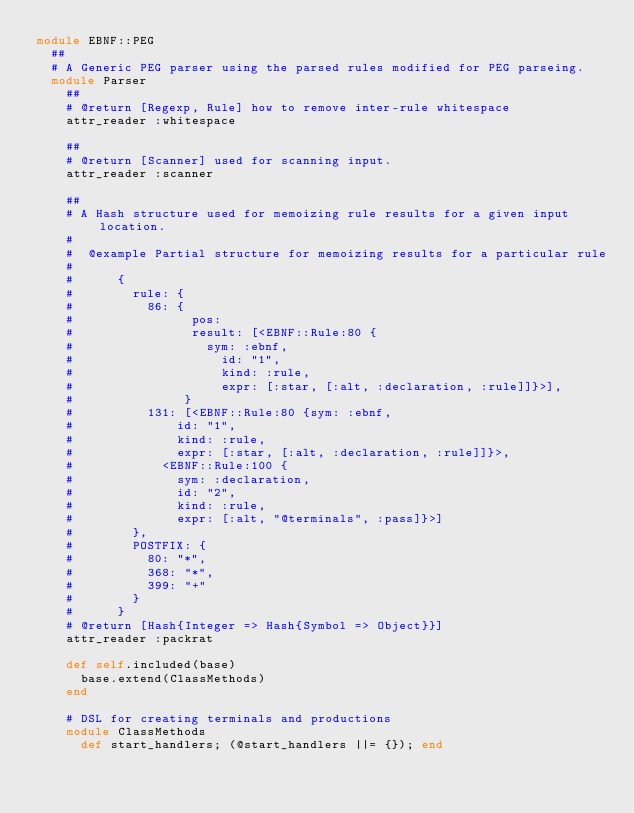<code> <loc_0><loc_0><loc_500><loc_500><_Ruby_>module EBNF::PEG
  ##
  # A Generic PEG parser using the parsed rules modified for PEG parseing.
  module Parser
    ##
    # @return [Regexp, Rule] how to remove inter-rule whitespace
    attr_reader :whitespace

    ##
    # @return [Scanner] used for scanning input.
    attr_reader :scanner

    ##
    # A Hash structure used for memoizing rule results for a given input location.
    #
    #  @example Partial structure for memoizing results for a particular rule
    #
    #      {
    #        rule: {
    #          86: {
    #                pos: 
    #                result: [<EBNF::Rule:80 {
    #                  sym: :ebnf,
    #                    id: "1",
    #                    kind: :rule,
    #                    expr: [:star, [:alt, :declaration, :rule]]}>],
    #               }
    #          131: [<EBNF::Rule:80 {sym: :ebnf,
    #              id: "1",
    #              kind: :rule,
    #              expr: [:star, [:alt, :declaration, :rule]]}>,
    #            <EBNF::Rule:100 {
    #              sym: :declaration,
    #              id: "2",
    #              kind: :rule,
    #              expr: [:alt, "@terminals", :pass]}>]
    #        },
    #        POSTFIX: {
    #          80: "*",
    #          368: "*",
    #          399: "+"
    #        }
    #      }
    # @return [Hash{Integer => Hash{Symbol => Object}}]
    attr_reader :packrat

    def self.included(base)
      base.extend(ClassMethods)
    end

    # DSL for creating terminals and productions
    module ClassMethods
      def start_handlers; (@start_handlers ||= {}); end</code> 